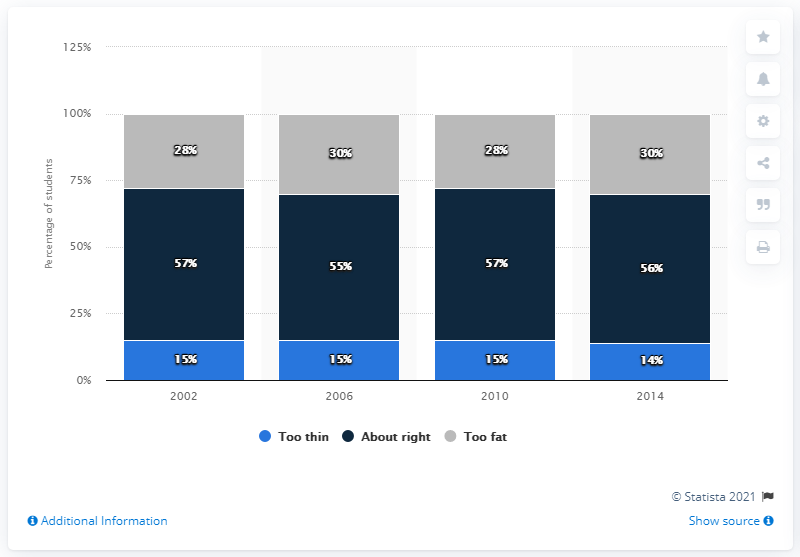Highlight a few significant elements in this photo. The sum of the highest value and lowest value of the light blue bar is 29. The value of the highest dark blue bar is 57. 